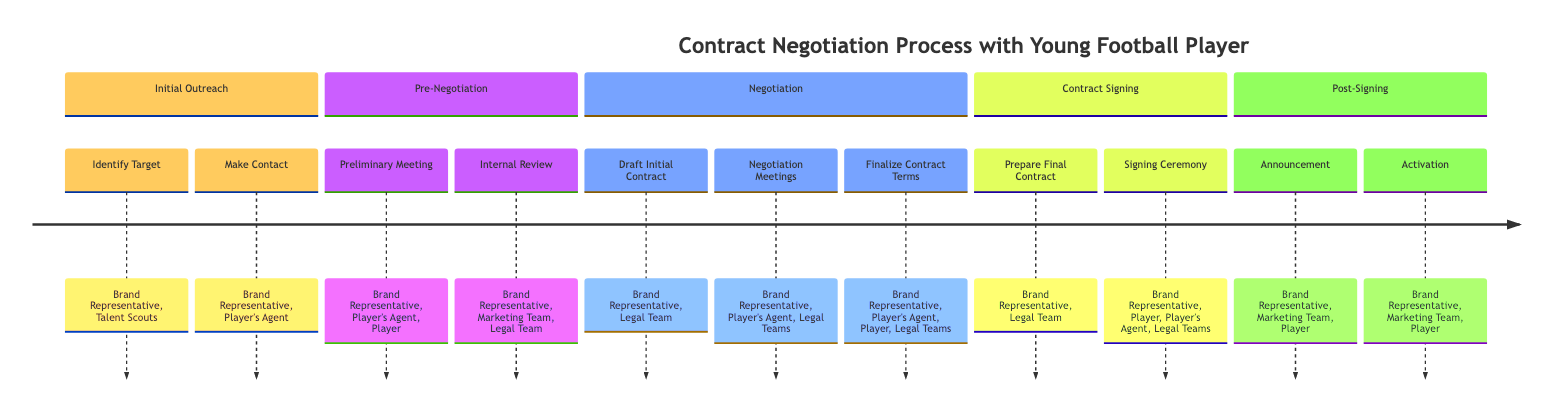What are the phases in the contract negotiation process? The diagram outlines five phases: Initial Outreach, Pre-Negotiation, Negotiation, Contract Signing, and Post-Signing. These phases are directly specified as sections in the timeline.
Answer: Initial Outreach, Pre-Negotiation, Negotiation, Contract Signing, Post-Signing How many steps are there in the Negotiation phase? The Negotiation phase consists of three steps: Draft Initial Contract, Negotiation Meetings, and Finalize Contract Terms. The diagram lists these steps within the Negotiation section.
Answer: 3 Who is involved in the Signing Ceremony? The Signing Ceremony involves the Brand Representative, Player, Player's Agent, and Legal Teams. This information is presented in the Contract Signing section of the diagram.
Answer: Brand Representative, Player, Player's Agent, Legal Teams What is the first step in the Pre-Negotiation phase? The first step in the Pre-Negotiation phase is Preliminary Meeting. The diagram provides a clear order of the steps within this phase.
Answer: Preliminary Meeting What happens after the Finalize Contract Terms step? After Finalize Contract Terms, the next step is to Prepare Final Contract, indicating a sequential flow in the timeline from negotiation to contract signing.
Answer: Prepare Final Contract Which teams evaluate the potential endorsement during the Internal Review? The Internal Review involves the Brand Representative, Marketing Team, and Legal Team. This is directly stated in the description of the Internal Review step in the Pre-Negotiation phase.
Answer: Brand Representative, Marketing Team, Legal Team What action is taken during the Post-Signing phase? The Post-Signing phase includes Announcement and Activation. These steps are clearly identified as actions taken after the contract signing in the timeline.
Answer: Announcement, Activation How many total steps are there across all phases? By counting all the steps in each phase, we find there are 12 steps in total, as listed in the diagram. This is a straightforward summation of individual steps.
Answer: 12 What do the Brand Representative and Player's Agent do during Negotiation Meetings? During Negotiation Meetings, the Brand Representative and Player's Agent discuss and revise contract terms. This interaction is specified in the Negotiation section of the diagram.
Answer: Discuss and revise contract terms 